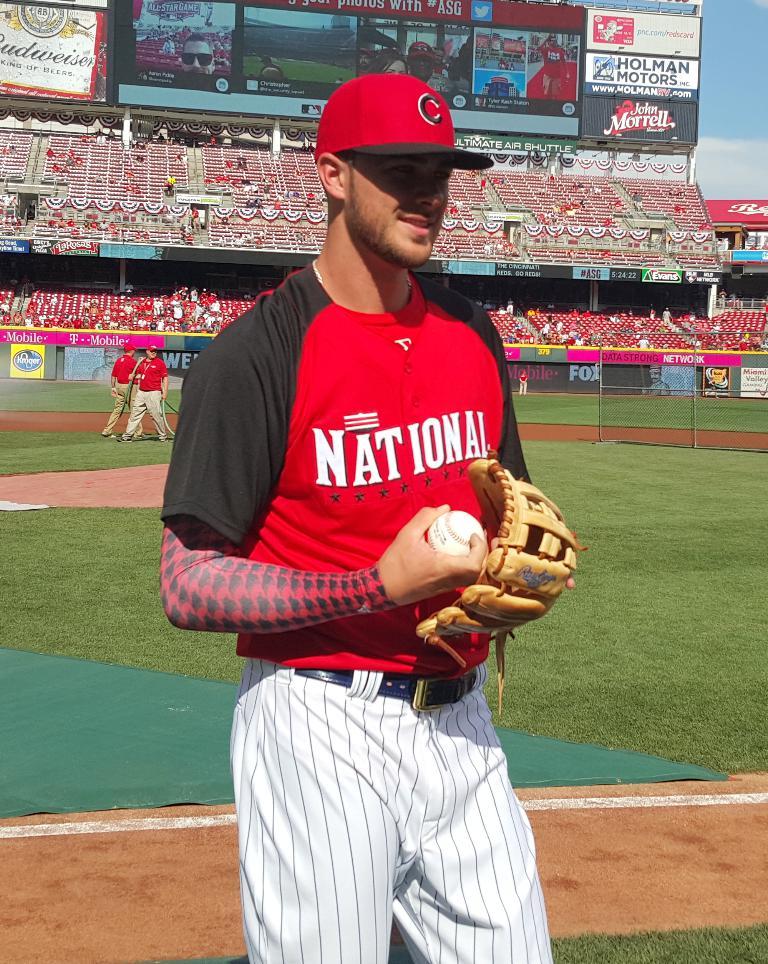What letter is on his cap?
Give a very brief answer. C. What is written on the mans chest?
Your answer should be compact. National. 